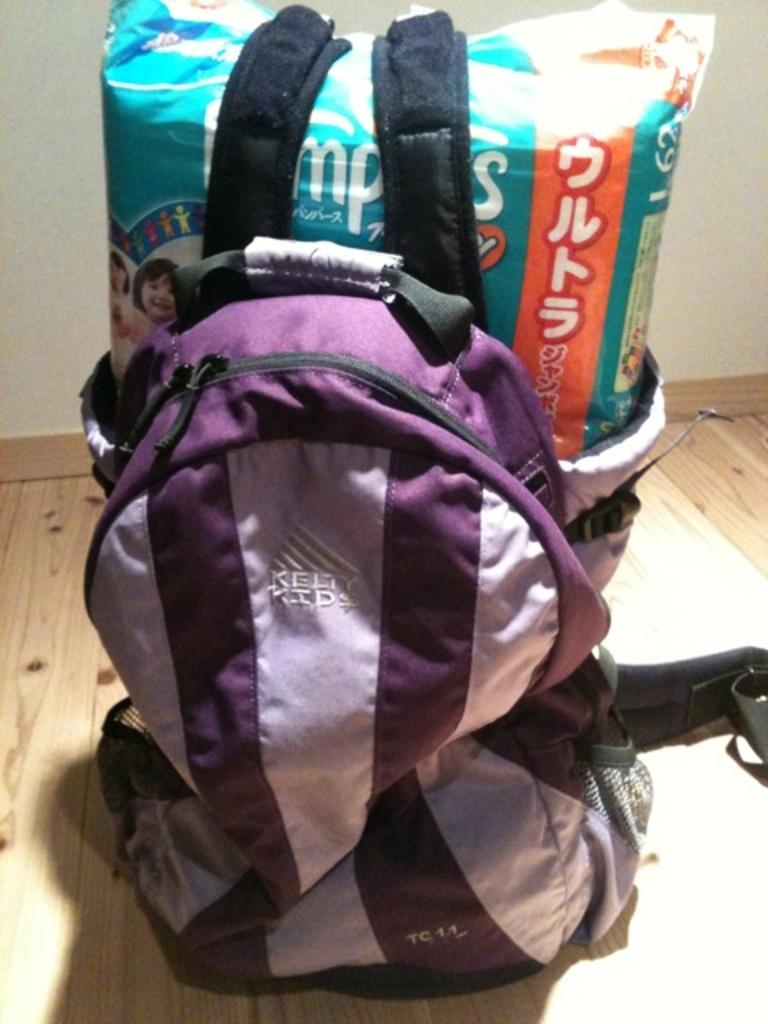What type of bag can be seen in the image? There is a pink bag in the image. What other item is present in the image? There is a pampers packet in the image. Where are the pink bag and pampers packet located? Both items are on the floor in the image. What can be seen in the background of the image? There is a wall visible in the background of the image. What time of day is it in the image, considering the presence of morning light? There is no mention of morning light or any indication of the time of day in the image. 